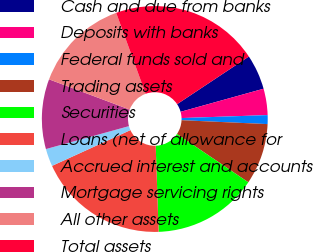Convert chart to OTSL. <chart><loc_0><loc_0><loc_500><loc_500><pie_chart><fcel>Cash and due from banks<fcel>Deposits with banks<fcel>Federal funds sold and<fcel>Trading assets<fcel>Securities<fcel>Loans (net of allowance for<fcel>Accrued interest and accounts<fcel>Mortgage servicing rights<fcel>All other assets<fcel>Total assets<nl><fcel>5.01%<fcel>3.77%<fcel>1.27%<fcel>8.75%<fcel>14.99%<fcel>18.73%<fcel>2.52%<fcel>10.0%<fcel>13.74%<fcel>21.22%<nl></chart> 